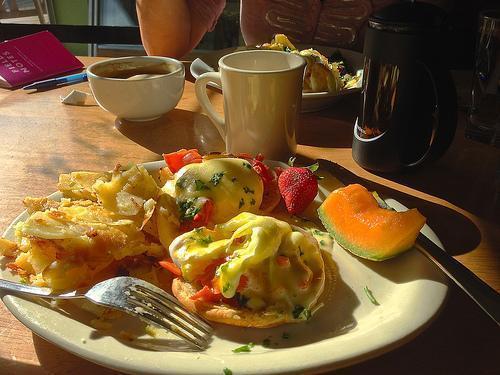How many knives are in the photo?
Give a very brief answer. 1. 